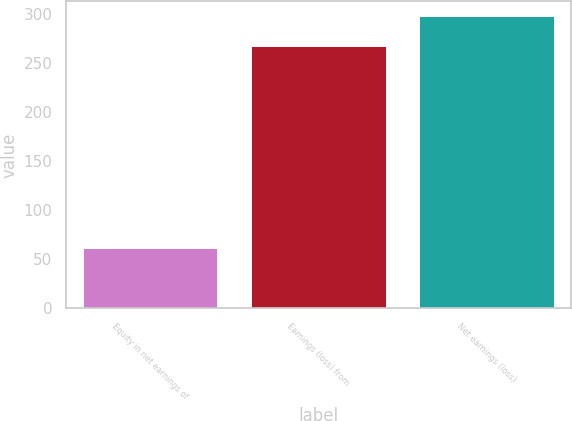<chart> <loc_0><loc_0><loc_500><loc_500><bar_chart><fcel>Equity in net earnings of<fcel>Earnings (loss) from<fcel>Net earnings (loss)<nl><fcel>61<fcel>268<fcel>298.1<nl></chart> 